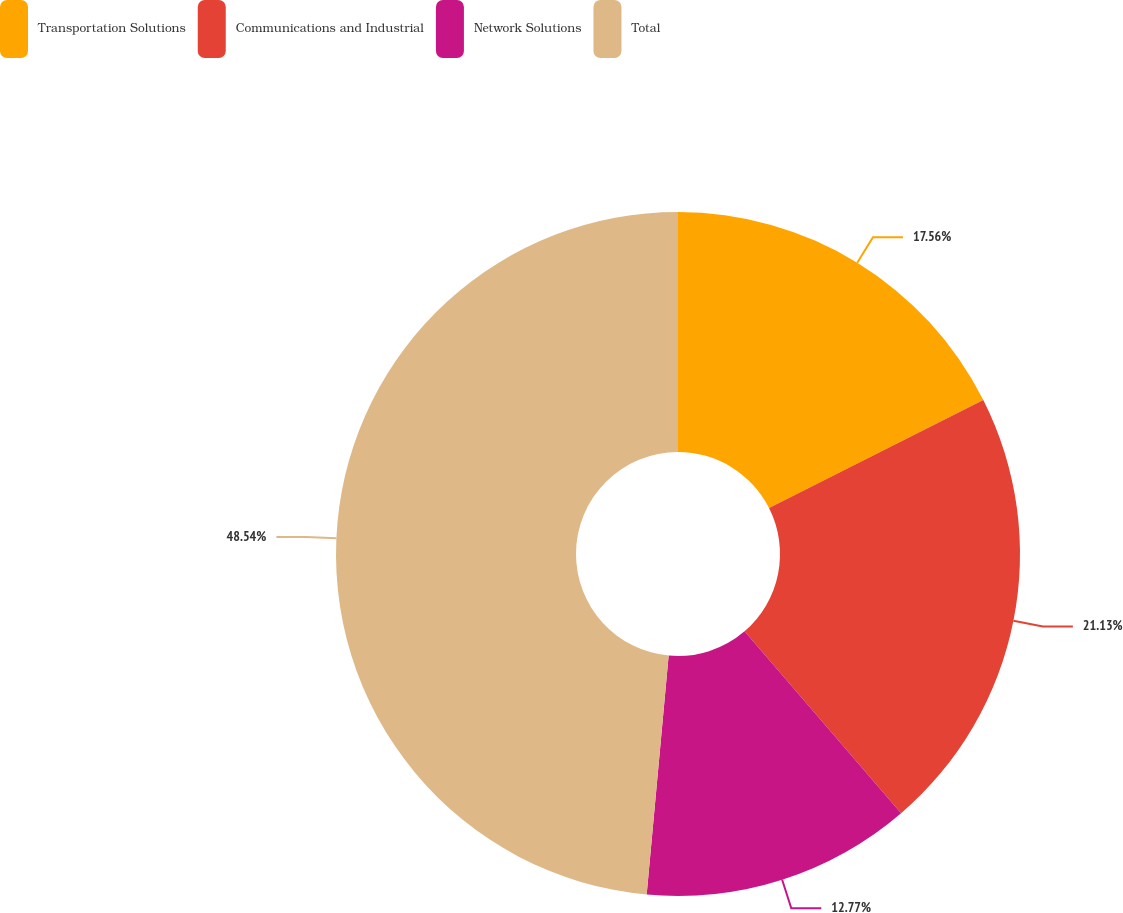Convert chart. <chart><loc_0><loc_0><loc_500><loc_500><pie_chart><fcel>Transportation Solutions<fcel>Communications and Industrial<fcel>Network Solutions<fcel>Total<nl><fcel>17.56%<fcel>21.13%<fcel>12.77%<fcel>48.54%<nl></chart> 